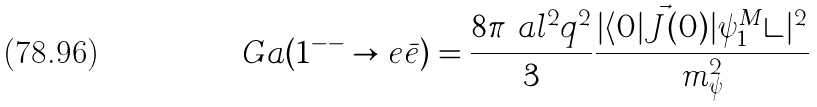Convert formula to latex. <formula><loc_0><loc_0><loc_500><loc_500>\ G a ( 1 ^ { - - } \to e \bar { e } ) = \frac { 8 \pi \ a l ^ { 2 } q ^ { 2 } } { 3 } \frac { | \langle 0 | \vec { J } ( 0 ) | \psi _ { 1 } ^ { M } \rangle | ^ { 2 } } { m _ { \psi } ^ { 2 } } \,</formula> 